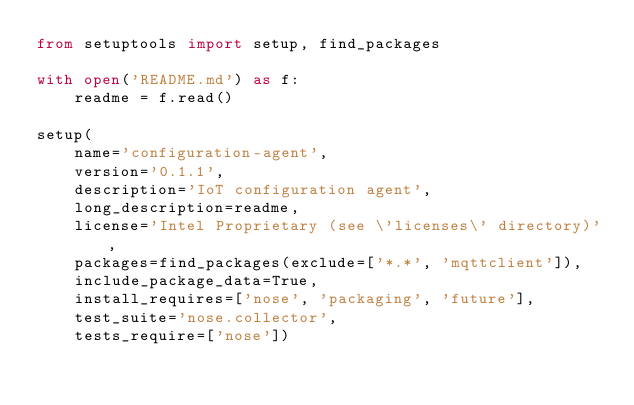<code> <loc_0><loc_0><loc_500><loc_500><_Python_>from setuptools import setup, find_packages

with open('README.md') as f:
    readme = f.read()

setup(
    name='configuration-agent',
    version='0.1.1',
    description='IoT configuration agent',
    long_description=readme,
    license='Intel Proprietary (see \'licenses\' directory)',
    packages=find_packages(exclude=['*.*', 'mqttclient']),
    include_package_data=True,
    install_requires=['nose', 'packaging', 'future'],
    test_suite='nose.collector',
    tests_require=['nose'])
</code> 